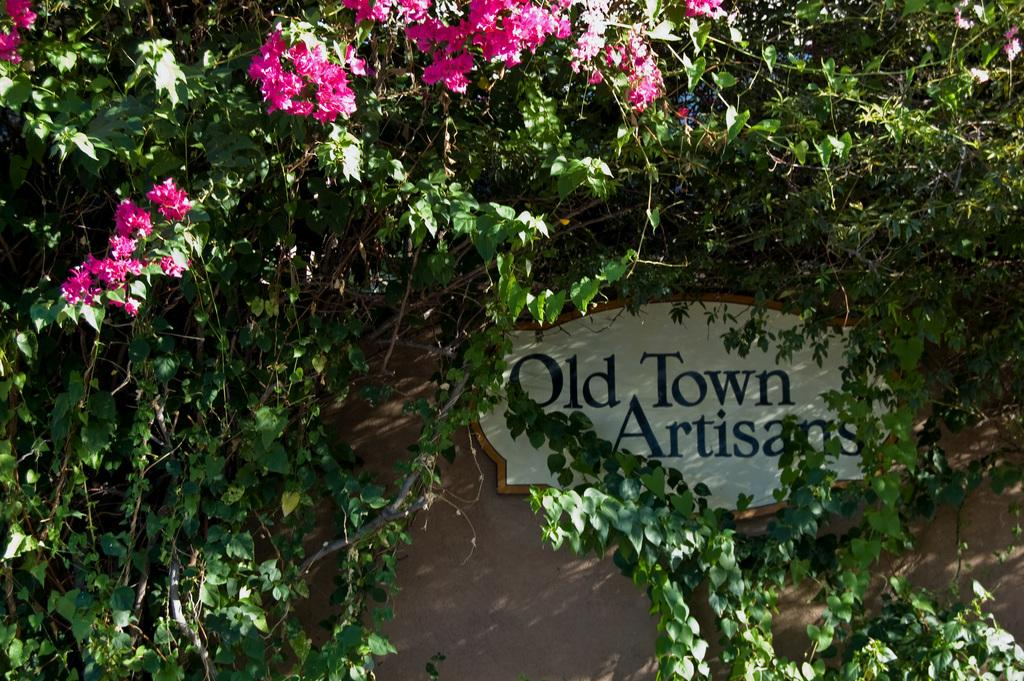What type of plants can be seen in the image? There are flowers and trees in the image. Can you describe the setting where the plants are located? The image features a natural setting with both flowers and trees. How many times does the flower express anger in the image? There is no flower expressing anger in the image, as flowers do not have emotions or the ability to express them. 